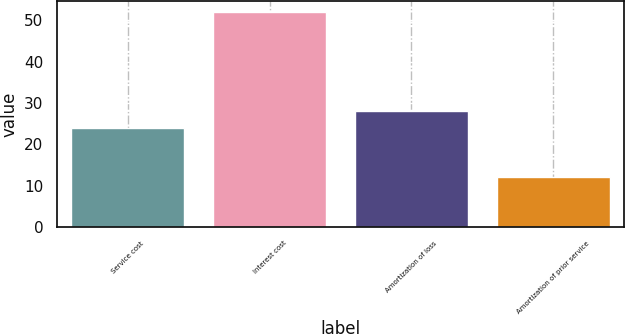Convert chart to OTSL. <chart><loc_0><loc_0><loc_500><loc_500><bar_chart><fcel>Service cost<fcel>Interest cost<fcel>Amortization of loss<fcel>Amortization of prior service<nl><fcel>24<fcel>52<fcel>28<fcel>12<nl></chart> 